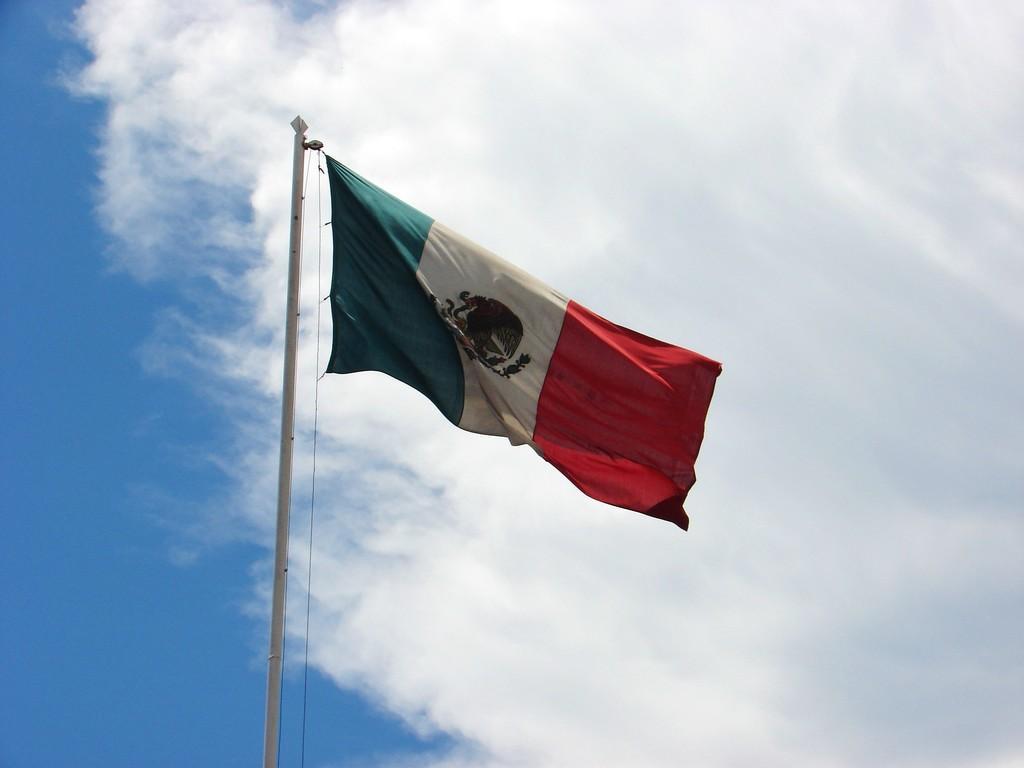Can you describe this image briefly? There is a flag on a pole. In the background there is sky with clouds. 